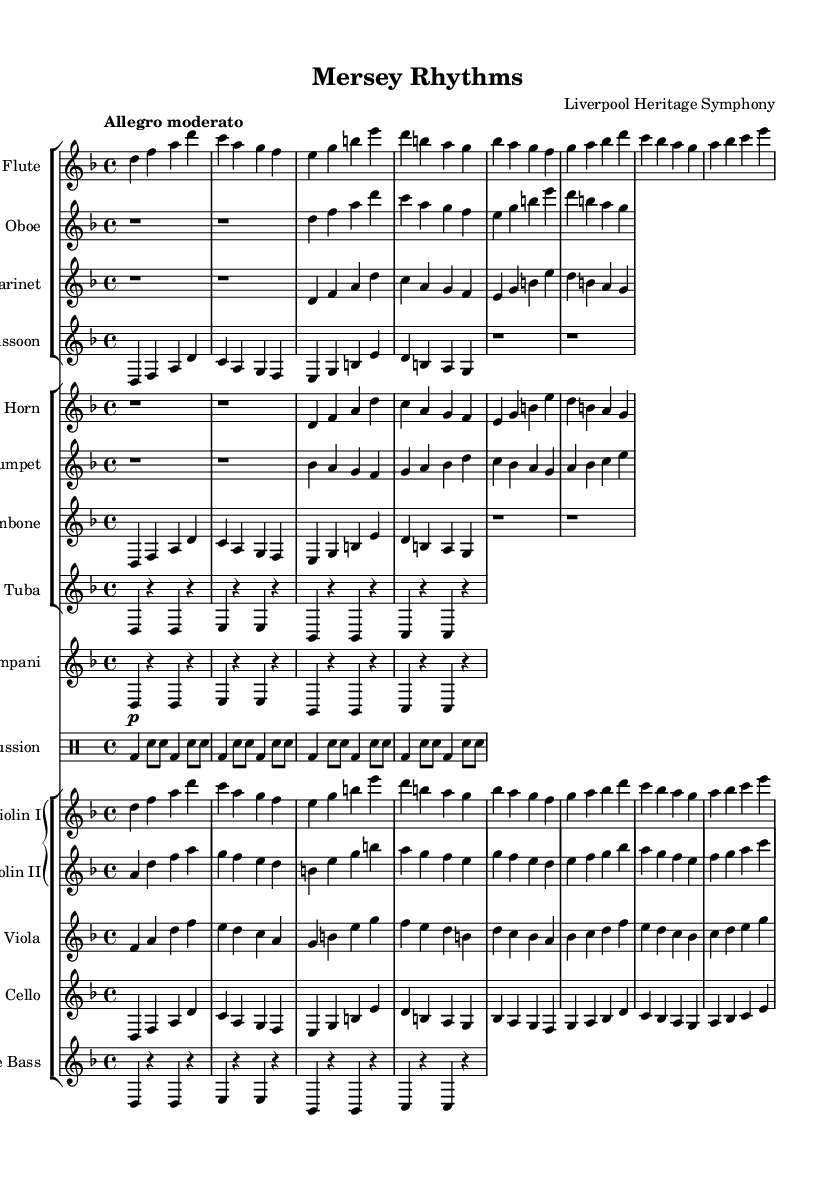What is the key signature of this symphony? The key signature is D minor, which is identified by one flat (B flat). It is shown at the beginning of the music staff.
Answer: D minor What is the time signature of this score? The time signature is 4/4, which indicates four beats in a measure and a quarter note receives one beat. This is displayed at the beginning of the piece.
Answer: 4/4 What is the tempo marking for this symphony? The tempo marking is "Allegro moderato," suggesting a moderately fast pace. This is noted at the beginning of the score.
Answer: Allegro moderato How many instruments are featured in this symphony's orchestration? There is a total of 14 instruments represented in the score, including strings, woodwinds, brass, and percussion. By counting the distinct staves, we can determine the number of instruments.
Answer: 14 Which woodwind instruments are included in this piece? The woodwind instruments included are flute, oboe, clarinet, and bassoon. This can be determined by identifying the staves labeled with these instrument names.
Answer: Flute, Oboe, Clarinet, Bassoon How many measures are present in the string section of this score? The string section consists of a total of 8 measures, evident from counting the groups of notes for each string instrument. Each group contains two measures for violins, viola, cello, and double bass.
Answer: 8 measures What notable feature does the percussion part have in terms of notation? The percussion part is notable for using a drum staff, which clearly delineates different percussion instruments using specific notations for bass drum and snare. This distinct staff helps to clarify rhythm and instrumentation in the percussion section.
Answer: Drum staff 